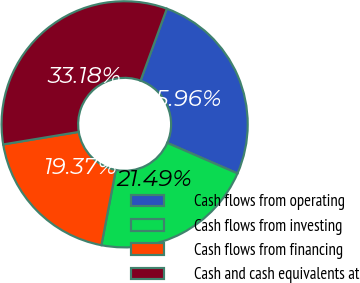Convert chart. <chart><loc_0><loc_0><loc_500><loc_500><pie_chart><fcel>Cash flows from operating<fcel>Cash flows from investing<fcel>Cash flows from financing<fcel>Cash and cash equivalents at<nl><fcel>25.96%<fcel>21.49%<fcel>19.37%<fcel>33.18%<nl></chart> 